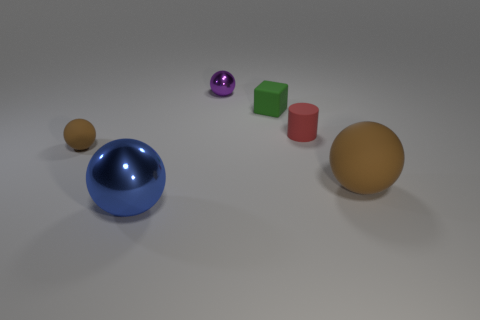What could the arrangement of these objects signify? The arrangement of objects might not have any particular significance beyond an artistic or demonstrative purpose. It could be a visual composition playing with shapes, colors, and materials to create a pleasing or thought-provoking presentation. Does the lighting have any effect on the appearance of the objects? Yes, the lighting greatly affects the appearance of the objects, casting soft shadows and highlights that emphasize their forms and textures. The blue sphere, due to its metallic surface, reflects light and surroundings, making it stand out among the other objects. 